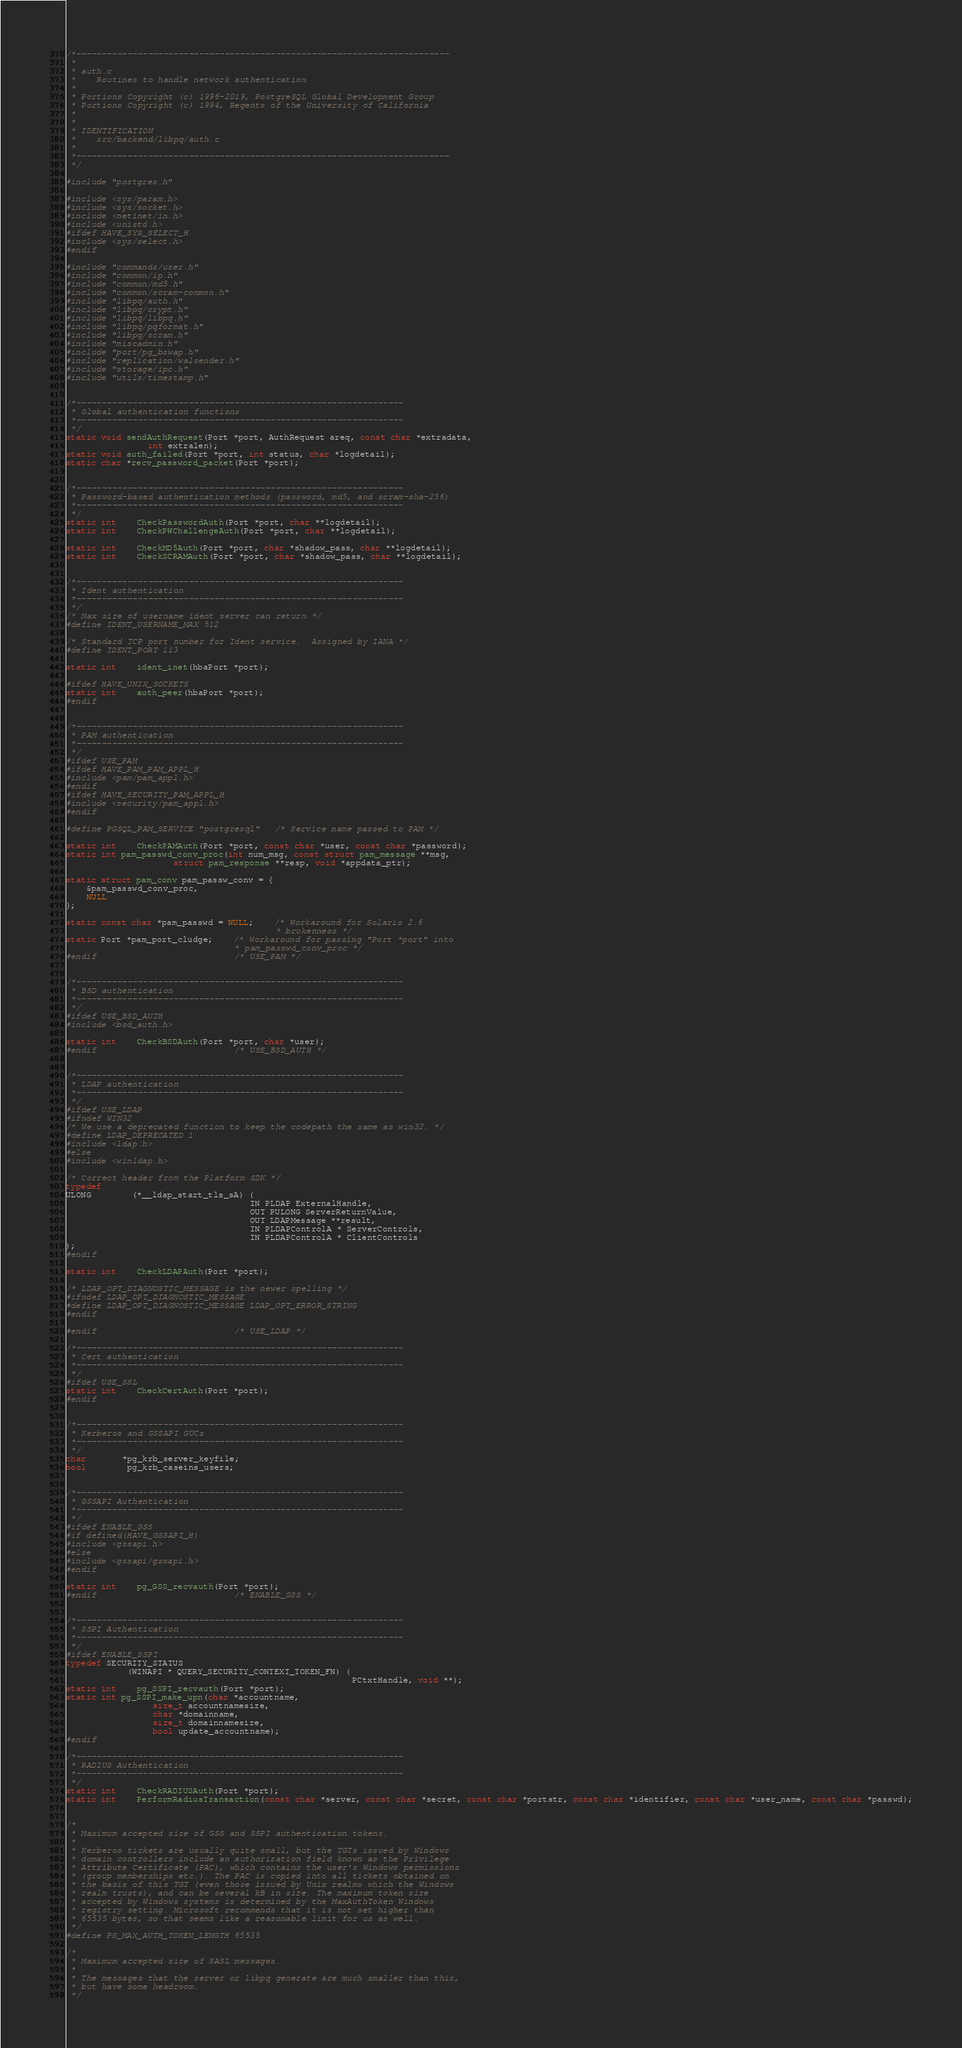<code> <loc_0><loc_0><loc_500><loc_500><_C_>/*-------------------------------------------------------------------------
 *
 * auth.c
 *	  Routines to handle network authentication
 *
 * Portions Copyright (c) 1996-2019, PostgreSQL Global Development Group
 * Portions Copyright (c) 1994, Regents of the University of California
 *
 *
 * IDENTIFICATION
 *	  src/backend/libpq/auth.c
 *
 *-------------------------------------------------------------------------
 */

#include "postgres.h"

#include <sys/param.h>
#include <sys/socket.h>
#include <netinet/in.h>
#include <unistd.h>
#ifdef HAVE_SYS_SELECT_H
#include <sys/select.h>
#endif

#include "commands/user.h"
#include "common/ip.h"
#include "common/md5.h"
#include "common/scram-common.h"
#include "libpq/auth.h"
#include "libpq/crypt.h"
#include "libpq/libpq.h"
#include "libpq/pqformat.h"
#include "libpq/scram.h"
#include "miscadmin.h"
#include "port/pg_bswap.h"
#include "replication/walsender.h"
#include "storage/ipc.h"
#include "utils/timestamp.h"


/*----------------------------------------------------------------
 * Global authentication functions
 *----------------------------------------------------------------
 */
static void sendAuthRequest(Port *port, AuthRequest areq, const char *extradata,
				int extralen);
static void auth_failed(Port *port, int status, char *logdetail);
static char *recv_password_packet(Port *port);


/*----------------------------------------------------------------
 * Password-based authentication methods (password, md5, and scram-sha-256)
 *----------------------------------------------------------------
 */
static int	CheckPasswordAuth(Port *port, char **logdetail);
static int	CheckPWChallengeAuth(Port *port, char **logdetail);

static int	CheckMD5Auth(Port *port, char *shadow_pass, char **logdetail);
static int	CheckSCRAMAuth(Port *port, char *shadow_pass, char **logdetail);


/*----------------------------------------------------------------
 * Ident authentication
 *----------------------------------------------------------------
 */
/* Max size of username ident server can return */
#define IDENT_USERNAME_MAX 512

/* Standard TCP port number for Ident service.  Assigned by IANA */
#define IDENT_PORT 113

static int	ident_inet(hbaPort *port);

#ifdef HAVE_UNIX_SOCKETS
static int	auth_peer(hbaPort *port);
#endif


/*----------------------------------------------------------------
 * PAM authentication
 *----------------------------------------------------------------
 */
#ifdef USE_PAM
#ifdef HAVE_PAM_PAM_APPL_H
#include <pam/pam_appl.h>
#endif
#ifdef HAVE_SECURITY_PAM_APPL_H
#include <security/pam_appl.h>
#endif

#define PGSQL_PAM_SERVICE "postgresql"	/* Service name passed to PAM */

static int	CheckPAMAuth(Port *port, const char *user, const char *password);
static int pam_passwd_conv_proc(int num_msg, const struct pam_message **msg,
					 struct pam_response **resp, void *appdata_ptr);

static struct pam_conv pam_passw_conv = {
	&pam_passwd_conv_proc,
	NULL
};

static const char *pam_passwd = NULL;	/* Workaround for Solaris 2.6
										 * brokenness */
static Port *pam_port_cludge;	/* Workaround for passing "Port *port" into
								 * pam_passwd_conv_proc */
#endif							/* USE_PAM */


/*----------------------------------------------------------------
 * BSD authentication
 *----------------------------------------------------------------
 */
#ifdef USE_BSD_AUTH
#include <bsd_auth.h>

static int	CheckBSDAuth(Port *port, char *user);
#endif							/* USE_BSD_AUTH */


/*----------------------------------------------------------------
 * LDAP authentication
 *----------------------------------------------------------------
 */
#ifdef USE_LDAP
#ifndef WIN32
/* We use a deprecated function to keep the codepath the same as win32. */
#define LDAP_DEPRECATED 1
#include <ldap.h>
#else
#include <winldap.h>

/* Correct header from the Platform SDK */
typedef
ULONG		(*__ldap_start_tls_sA) (
									IN PLDAP ExternalHandle,
									OUT PULONG ServerReturnValue,
									OUT LDAPMessage **result,
									IN PLDAPControlA * ServerControls,
									IN PLDAPControlA * ClientControls
);
#endif

static int	CheckLDAPAuth(Port *port);

/* LDAP_OPT_DIAGNOSTIC_MESSAGE is the newer spelling */
#ifndef LDAP_OPT_DIAGNOSTIC_MESSAGE
#define LDAP_OPT_DIAGNOSTIC_MESSAGE LDAP_OPT_ERROR_STRING
#endif

#endif							/* USE_LDAP */

/*----------------------------------------------------------------
 * Cert authentication
 *----------------------------------------------------------------
 */
#ifdef USE_SSL
static int	CheckCertAuth(Port *port);
#endif


/*----------------------------------------------------------------
 * Kerberos and GSSAPI GUCs
 *----------------------------------------------------------------
 */
char	   *pg_krb_server_keyfile;
bool		pg_krb_caseins_users;


/*----------------------------------------------------------------
 * GSSAPI Authentication
 *----------------------------------------------------------------
 */
#ifdef ENABLE_GSS
#if defined(HAVE_GSSAPI_H)
#include <gssapi.h>
#else
#include <gssapi/gssapi.h>
#endif

static int	pg_GSS_recvauth(Port *port);
#endif							/* ENABLE_GSS */


/*----------------------------------------------------------------
 * SSPI Authentication
 *----------------------------------------------------------------
 */
#ifdef ENABLE_SSPI
typedef SECURITY_STATUS
			(WINAPI * QUERY_SECURITY_CONTEXT_TOKEN_FN) (
														PCtxtHandle, void **);
static int	pg_SSPI_recvauth(Port *port);
static int pg_SSPI_make_upn(char *accountname,
				 size_t accountnamesize,
				 char *domainname,
				 size_t domainnamesize,
				 bool update_accountname);
#endif

/*----------------------------------------------------------------
 * RADIUS Authentication
 *----------------------------------------------------------------
 */
static int	CheckRADIUSAuth(Port *port);
static int	PerformRadiusTransaction(const char *server, const char *secret, const char *portstr, const char *identifier, const char *user_name, const char *passwd);


/*
 * Maximum accepted size of GSS and SSPI authentication tokens.
 *
 * Kerberos tickets are usually quite small, but the TGTs issued by Windows
 * domain controllers include an authorization field known as the Privilege
 * Attribute Certificate (PAC), which contains the user's Windows permissions
 * (group memberships etc.). The PAC is copied into all tickets obtained on
 * the basis of this TGT (even those issued by Unix realms which the Windows
 * realm trusts), and can be several kB in size. The maximum token size
 * accepted by Windows systems is determined by the MaxAuthToken Windows
 * registry setting. Microsoft recommends that it is not set higher than
 * 65535 bytes, so that seems like a reasonable limit for us as well.
 */
#define PG_MAX_AUTH_TOKEN_LENGTH	65535

/*
 * Maximum accepted size of SASL messages.
 *
 * The messages that the server or libpq generate are much smaller than this,
 * but have some headroom.
 */</code> 